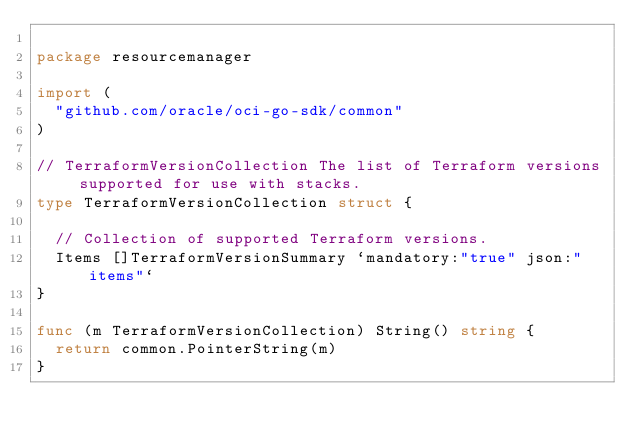Convert code to text. <code><loc_0><loc_0><loc_500><loc_500><_Go_>
package resourcemanager

import (
	"github.com/oracle/oci-go-sdk/common"
)

// TerraformVersionCollection The list of Terraform versions supported for use with stacks.
type TerraformVersionCollection struct {

	// Collection of supported Terraform versions.
	Items []TerraformVersionSummary `mandatory:"true" json:"items"`
}

func (m TerraformVersionCollection) String() string {
	return common.PointerString(m)
}
</code> 